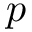<formula> <loc_0><loc_0><loc_500><loc_500>p</formula> 